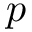<formula> <loc_0><loc_0><loc_500><loc_500>p</formula> 